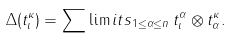Convert formula to latex. <formula><loc_0><loc_0><loc_500><loc_500>\Delta ( t _ { \iota } ^ { \kappa } ) = \sum \lim i t s _ { 1 \leq \alpha \leq n } \, t _ { \iota } ^ { \alpha } \otimes t _ { \alpha } ^ { \kappa } .</formula> 